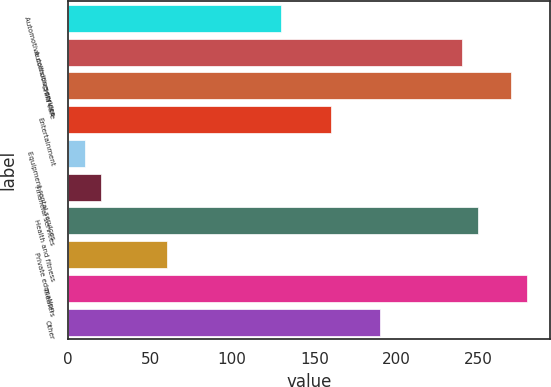Convert chart. <chart><loc_0><loc_0><loc_500><loc_500><bar_chart><fcel>Automotive collision services<fcel>Automotive service<fcel>Child care<fcel>Entertainment<fcel>Equipment rental services<fcel>Financial services<fcel>Health and fitness<fcel>Private education<fcel>Theaters<fcel>Other<nl><fcel>129.97<fcel>239.86<fcel>269.83<fcel>159.94<fcel>10.09<fcel>20.08<fcel>249.85<fcel>60.04<fcel>279.82<fcel>189.91<nl></chart> 